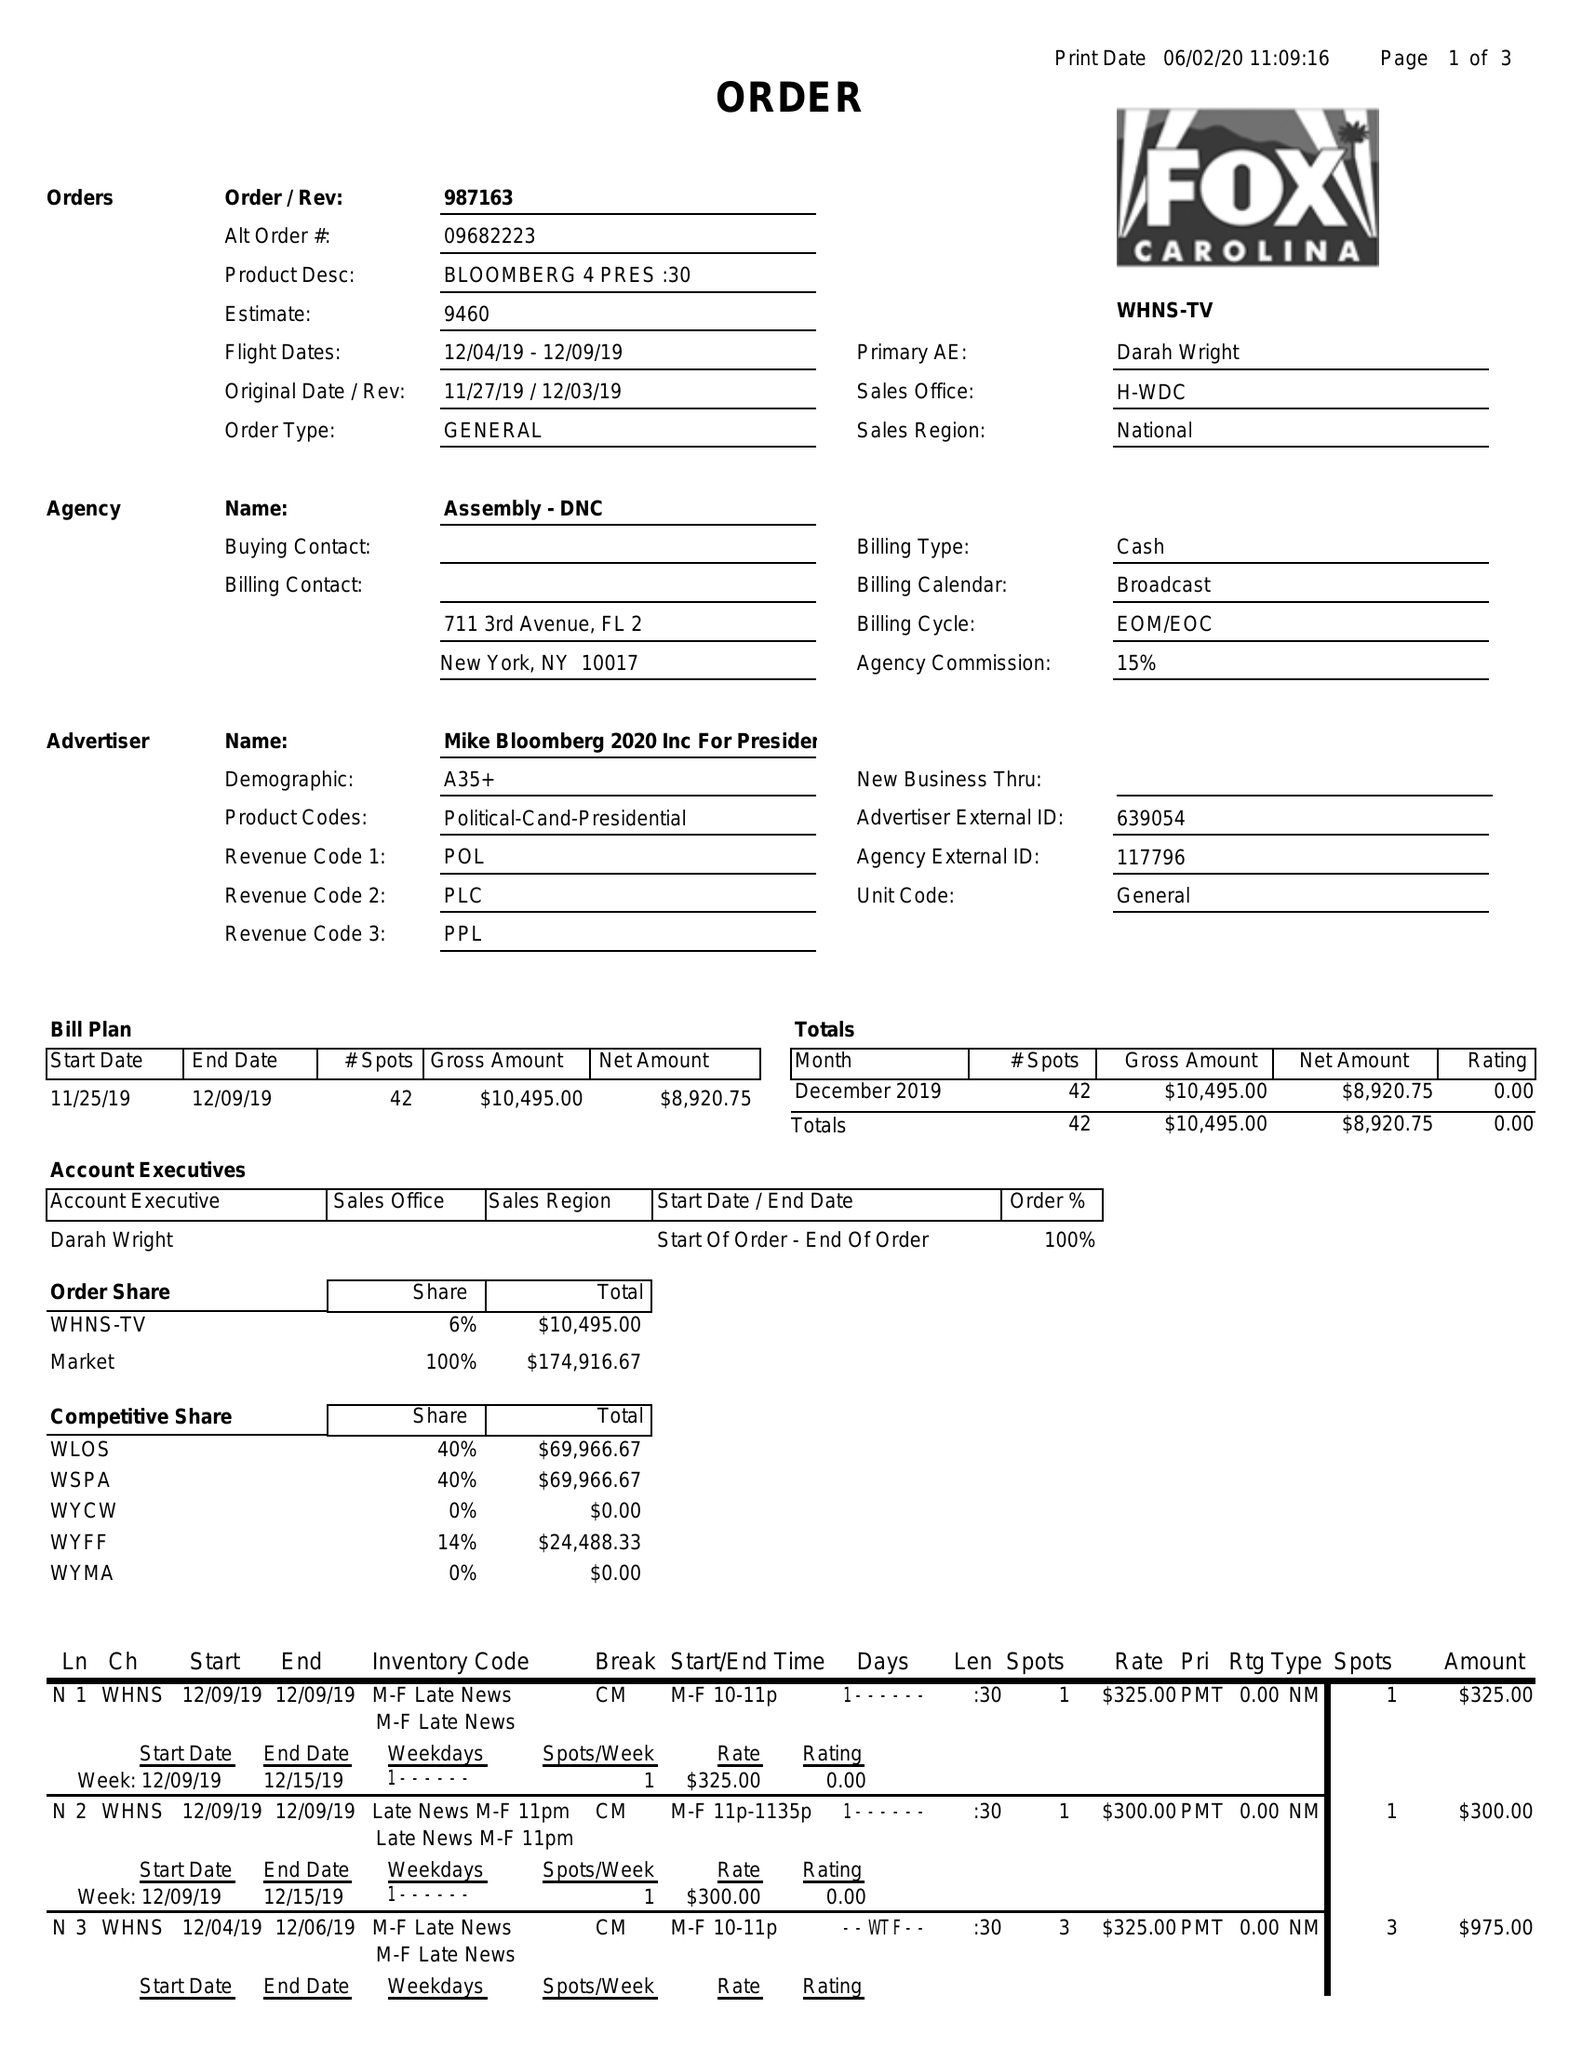What is the value for the advertiser?
Answer the question using a single word or phrase. MIKEBLOOMBERG2020INCFORPRESIDENTC/O 